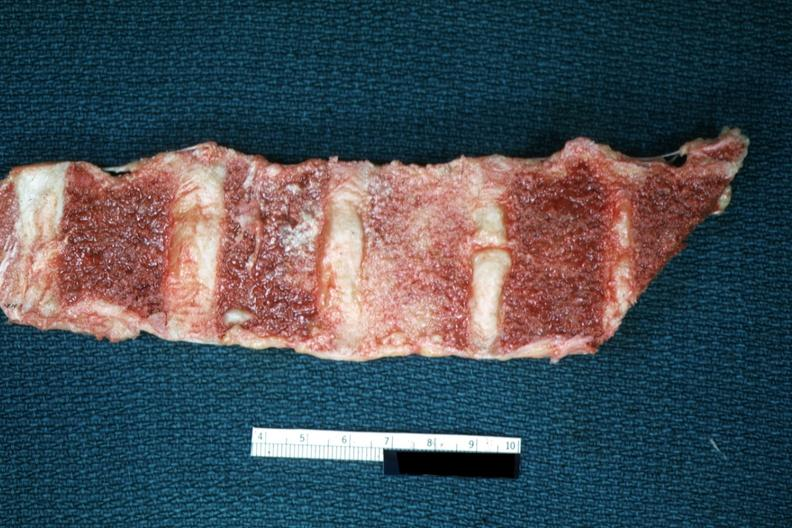what is present?
Answer the question using a single word or phrase. Joints 